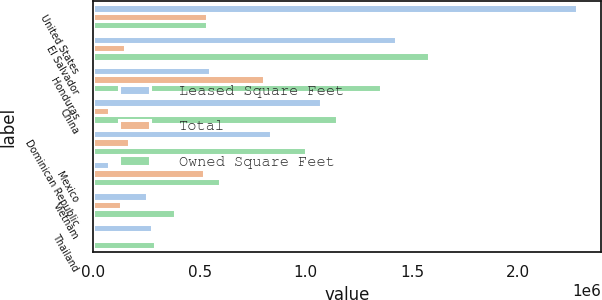Convert chart to OTSL. <chart><loc_0><loc_0><loc_500><loc_500><stacked_bar_chart><ecel><fcel>United States<fcel>El Salvador<fcel>Honduras<fcel>China<fcel>Dominican Republic<fcel>Mexico<fcel>Vietnam<fcel>Thailand<nl><fcel>Leased Square Feet<fcel>2.27689e+06<fcel>1.42687e+06<fcel>548921<fcel>1.07091e+06<fcel>835240<fcel>75255<fcel>251337<fcel>277733<nl><fcel>Total<fcel>534984<fcel>150951<fcel>805464<fcel>73884<fcel>166033<fcel>521048<fcel>131735<fcel>14142<nl><fcel>Owned Square Feet<fcel>534984<fcel>1.57782e+06<fcel>1.35438e+06<fcel>1.1448e+06<fcel>1.00127e+06<fcel>596303<fcel>383072<fcel>291875<nl></chart> 